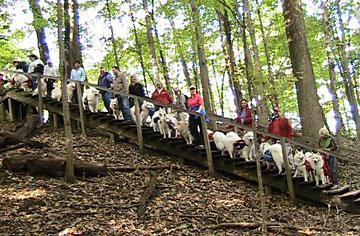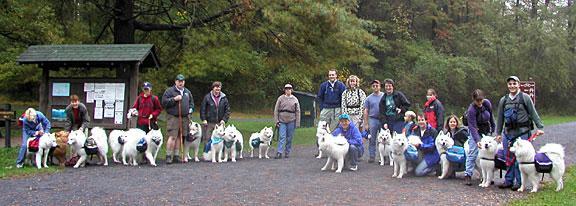The first image is the image on the left, the second image is the image on the right. Assess this claim about the two images: "AN image shows just one person posed behind one big white dog outdoors.". Correct or not? Answer yes or no. No. The first image is the image on the left, the second image is the image on the right. For the images shown, is this caption "White dogs are standing on a rocky edge." true? Answer yes or no. No. 